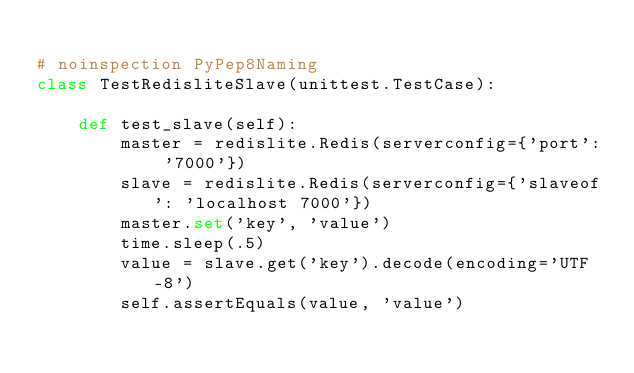<code> <loc_0><loc_0><loc_500><loc_500><_Python_>
# noinspection PyPep8Naming
class TestRedisliteSlave(unittest.TestCase):

    def test_slave(self):
        master = redislite.Redis(serverconfig={'port': '7000'})
        slave = redislite.Redis(serverconfig={'slaveof': 'localhost 7000'})
        master.set('key', 'value')
        time.sleep(.5)
        value = slave.get('key').decode(encoding='UTF-8')
        self.assertEquals(value, 'value')
</code> 